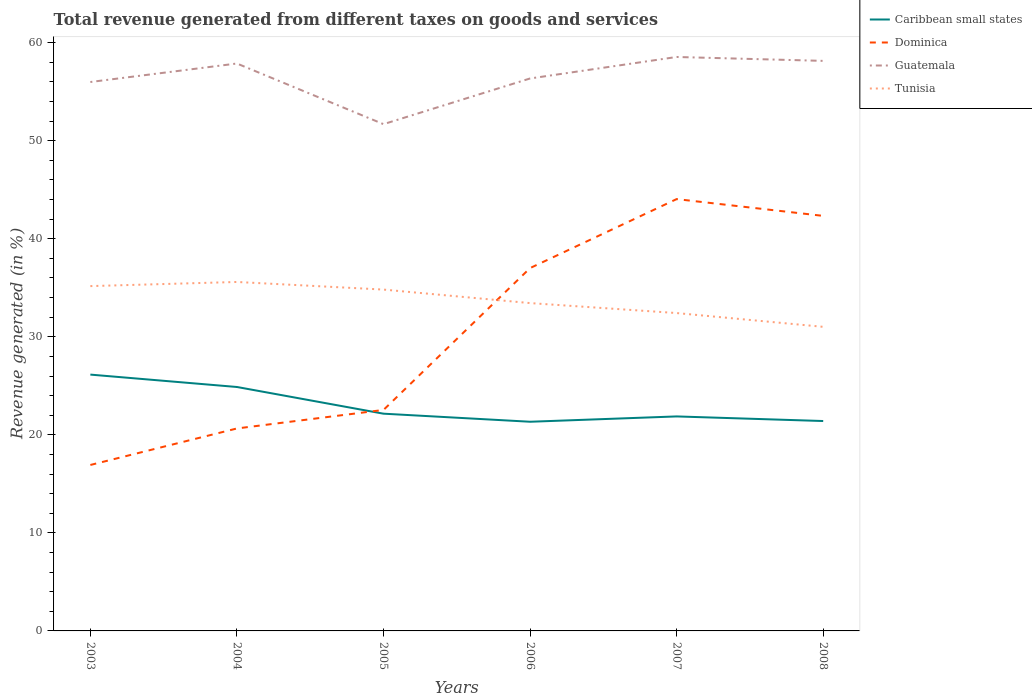How many different coloured lines are there?
Make the answer very short. 4. Across all years, what is the maximum total revenue generated in Tunisia?
Provide a succinct answer. 31.02. What is the total total revenue generated in Caribbean small states in the graph?
Your response must be concise. 1.26. What is the difference between the highest and the second highest total revenue generated in Guatemala?
Provide a succinct answer. 6.85. Is the total revenue generated in Tunisia strictly greater than the total revenue generated in Dominica over the years?
Keep it short and to the point. No. How many lines are there?
Your response must be concise. 4. How many years are there in the graph?
Your response must be concise. 6. What is the difference between two consecutive major ticks on the Y-axis?
Offer a very short reply. 10. Does the graph contain any zero values?
Ensure brevity in your answer.  No. Does the graph contain grids?
Provide a succinct answer. No. How many legend labels are there?
Provide a succinct answer. 4. How are the legend labels stacked?
Make the answer very short. Vertical. What is the title of the graph?
Make the answer very short. Total revenue generated from different taxes on goods and services. Does "Virgin Islands" appear as one of the legend labels in the graph?
Your response must be concise. No. What is the label or title of the Y-axis?
Offer a terse response. Revenue generated (in %). What is the Revenue generated (in %) in Caribbean small states in 2003?
Offer a very short reply. 26.14. What is the Revenue generated (in %) in Dominica in 2003?
Keep it short and to the point. 16.93. What is the Revenue generated (in %) in Guatemala in 2003?
Your answer should be very brief. 55.99. What is the Revenue generated (in %) in Tunisia in 2003?
Your answer should be compact. 35.17. What is the Revenue generated (in %) of Caribbean small states in 2004?
Ensure brevity in your answer.  24.88. What is the Revenue generated (in %) in Dominica in 2004?
Provide a succinct answer. 20.65. What is the Revenue generated (in %) in Guatemala in 2004?
Your response must be concise. 57.87. What is the Revenue generated (in %) of Tunisia in 2004?
Ensure brevity in your answer.  35.59. What is the Revenue generated (in %) of Caribbean small states in 2005?
Provide a succinct answer. 22.16. What is the Revenue generated (in %) in Dominica in 2005?
Provide a short and direct response. 22.54. What is the Revenue generated (in %) in Guatemala in 2005?
Ensure brevity in your answer.  51.69. What is the Revenue generated (in %) of Tunisia in 2005?
Provide a succinct answer. 34.82. What is the Revenue generated (in %) of Caribbean small states in 2006?
Ensure brevity in your answer.  21.34. What is the Revenue generated (in %) of Dominica in 2006?
Keep it short and to the point. 37.01. What is the Revenue generated (in %) of Guatemala in 2006?
Your response must be concise. 56.35. What is the Revenue generated (in %) of Tunisia in 2006?
Make the answer very short. 33.44. What is the Revenue generated (in %) of Caribbean small states in 2007?
Offer a terse response. 21.88. What is the Revenue generated (in %) of Dominica in 2007?
Offer a terse response. 44.04. What is the Revenue generated (in %) of Guatemala in 2007?
Provide a short and direct response. 58.54. What is the Revenue generated (in %) in Tunisia in 2007?
Offer a very short reply. 32.42. What is the Revenue generated (in %) of Caribbean small states in 2008?
Keep it short and to the point. 21.41. What is the Revenue generated (in %) of Dominica in 2008?
Offer a terse response. 42.33. What is the Revenue generated (in %) of Guatemala in 2008?
Your answer should be compact. 58.14. What is the Revenue generated (in %) in Tunisia in 2008?
Your response must be concise. 31.02. Across all years, what is the maximum Revenue generated (in %) in Caribbean small states?
Offer a very short reply. 26.14. Across all years, what is the maximum Revenue generated (in %) in Dominica?
Make the answer very short. 44.04. Across all years, what is the maximum Revenue generated (in %) of Guatemala?
Provide a succinct answer. 58.54. Across all years, what is the maximum Revenue generated (in %) of Tunisia?
Provide a succinct answer. 35.59. Across all years, what is the minimum Revenue generated (in %) of Caribbean small states?
Offer a terse response. 21.34. Across all years, what is the minimum Revenue generated (in %) of Dominica?
Ensure brevity in your answer.  16.93. Across all years, what is the minimum Revenue generated (in %) in Guatemala?
Give a very brief answer. 51.69. Across all years, what is the minimum Revenue generated (in %) in Tunisia?
Offer a terse response. 31.02. What is the total Revenue generated (in %) of Caribbean small states in the graph?
Ensure brevity in your answer.  137.8. What is the total Revenue generated (in %) in Dominica in the graph?
Your response must be concise. 183.5. What is the total Revenue generated (in %) of Guatemala in the graph?
Provide a succinct answer. 338.58. What is the total Revenue generated (in %) of Tunisia in the graph?
Give a very brief answer. 202.45. What is the difference between the Revenue generated (in %) of Caribbean small states in 2003 and that in 2004?
Your response must be concise. 1.26. What is the difference between the Revenue generated (in %) of Dominica in 2003 and that in 2004?
Your answer should be very brief. -3.72. What is the difference between the Revenue generated (in %) of Guatemala in 2003 and that in 2004?
Provide a short and direct response. -1.89. What is the difference between the Revenue generated (in %) of Tunisia in 2003 and that in 2004?
Your answer should be compact. -0.42. What is the difference between the Revenue generated (in %) in Caribbean small states in 2003 and that in 2005?
Provide a short and direct response. 3.99. What is the difference between the Revenue generated (in %) of Dominica in 2003 and that in 2005?
Keep it short and to the point. -5.61. What is the difference between the Revenue generated (in %) of Guatemala in 2003 and that in 2005?
Give a very brief answer. 4.3. What is the difference between the Revenue generated (in %) of Tunisia in 2003 and that in 2005?
Provide a short and direct response. 0.35. What is the difference between the Revenue generated (in %) in Caribbean small states in 2003 and that in 2006?
Ensure brevity in your answer.  4.81. What is the difference between the Revenue generated (in %) of Dominica in 2003 and that in 2006?
Provide a succinct answer. -20.08. What is the difference between the Revenue generated (in %) in Guatemala in 2003 and that in 2006?
Give a very brief answer. -0.36. What is the difference between the Revenue generated (in %) of Tunisia in 2003 and that in 2006?
Give a very brief answer. 1.73. What is the difference between the Revenue generated (in %) in Caribbean small states in 2003 and that in 2007?
Make the answer very short. 4.27. What is the difference between the Revenue generated (in %) of Dominica in 2003 and that in 2007?
Provide a succinct answer. -27.12. What is the difference between the Revenue generated (in %) of Guatemala in 2003 and that in 2007?
Keep it short and to the point. -2.55. What is the difference between the Revenue generated (in %) of Tunisia in 2003 and that in 2007?
Keep it short and to the point. 2.75. What is the difference between the Revenue generated (in %) in Caribbean small states in 2003 and that in 2008?
Keep it short and to the point. 4.74. What is the difference between the Revenue generated (in %) of Dominica in 2003 and that in 2008?
Make the answer very short. -25.41. What is the difference between the Revenue generated (in %) in Guatemala in 2003 and that in 2008?
Ensure brevity in your answer.  -2.15. What is the difference between the Revenue generated (in %) of Tunisia in 2003 and that in 2008?
Your answer should be very brief. 4.15. What is the difference between the Revenue generated (in %) of Caribbean small states in 2004 and that in 2005?
Your answer should be compact. 2.72. What is the difference between the Revenue generated (in %) in Dominica in 2004 and that in 2005?
Make the answer very short. -1.89. What is the difference between the Revenue generated (in %) in Guatemala in 2004 and that in 2005?
Keep it short and to the point. 6.19. What is the difference between the Revenue generated (in %) of Tunisia in 2004 and that in 2005?
Provide a short and direct response. 0.78. What is the difference between the Revenue generated (in %) of Caribbean small states in 2004 and that in 2006?
Give a very brief answer. 3.54. What is the difference between the Revenue generated (in %) in Dominica in 2004 and that in 2006?
Offer a terse response. -16.36. What is the difference between the Revenue generated (in %) of Guatemala in 2004 and that in 2006?
Offer a terse response. 1.53. What is the difference between the Revenue generated (in %) of Tunisia in 2004 and that in 2006?
Keep it short and to the point. 2.15. What is the difference between the Revenue generated (in %) in Caribbean small states in 2004 and that in 2007?
Your answer should be compact. 3. What is the difference between the Revenue generated (in %) in Dominica in 2004 and that in 2007?
Provide a short and direct response. -23.39. What is the difference between the Revenue generated (in %) of Guatemala in 2004 and that in 2007?
Ensure brevity in your answer.  -0.67. What is the difference between the Revenue generated (in %) of Tunisia in 2004 and that in 2007?
Your answer should be compact. 3.17. What is the difference between the Revenue generated (in %) of Caribbean small states in 2004 and that in 2008?
Provide a short and direct response. 3.47. What is the difference between the Revenue generated (in %) in Dominica in 2004 and that in 2008?
Keep it short and to the point. -21.68. What is the difference between the Revenue generated (in %) of Guatemala in 2004 and that in 2008?
Make the answer very short. -0.27. What is the difference between the Revenue generated (in %) of Tunisia in 2004 and that in 2008?
Your response must be concise. 4.58. What is the difference between the Revenue generated (in %) of Caribbean small states in 2005 and that in 2006?
Give a very brief answer. 0.82. What is the difference between the Revenue generated (in %) in Dominica in 2005 and that in 2006?
Make the answer very short. -14.47. What is the difference between the Revenue generated (in %) of Guatemala in 2005 and that in 2006?
Make the answer very short. -4.66. What is the difference between the Revenue generated (in %) of Tunisia in 2005 and that in 2006?
Your answer should be compact. 1.38. What is the difference between the Revenue generated (in %) in Caribbean small states in 2005 and that in 2007?
Your answer should be very brief. 0.28. What is the difference between the Revenue generated (in %) of Dominica in 2005 and that in 2007?
Provide a succinct answer. -21.51. What is the difference between the Revenue generated (in %) in Guatemala in 2005 and that in 2007?
Offer a terse response. -6.85. What is the difference between the Revenue generated (in %) in Tunisia in 2005 and that in 2007?
Offer a very short reply. 2.39. What is the difference between the Revenue generated (in %) in Caribbean small states in 2005 and that in 2008?
Give a very brief answer. 0.75. What is the difference between the Revenue generated (in %) in Dominica in 2005 and that in 2008?
Your answer should be compact. -19.79. What is the difference between the Revenue generated (in %) in Guatemala in 2005 and that in 2008?
Offer a terse response. -6.45. What is the difference between the Revenue generated (in %) of Tunisia in 2005 and that in 2008?
Provide a short and direct response. 3.8. What is the difference between the Revenue generated (in %) of Caribbean small states in 2006 and that in 2007?
Offer a terse response. -0.54. What is the difference between the Revenue generated (in %) of Dominica in 2006 and that in 2007?
Keep it short and to the point. -7.04. What is the difference between the Revenue generated (in %) in Guatemala in 2006 and that in 2007?
Provide a succinct answer. -2.19. What is the difference between the Revenue generated (in %) of Tunisia in 2006 and that in 2007?
Keep it short and to the point. 1.02. What is the difference between the Revenue generated (in %) of Caribbean small states in 2006 and that in 2008?
Offer a terse response. -0.07. What is the difference between the Revenue generated (in %) in Dominica in 2006 and that in 2008?
Make the answer very short. -5.32. What is the difference between the Revenue generated (in %) of Guatemala in 2006 and that in 2008?
Ensure brevity in your answer.  -1.79. What is the difference between the Revenue generated (in %) in Tunisia in 2006 and that in 2008?
Your answer should be compact. 2.42. What is the difference between the Revenue generated (in %) of Caribbean small states in 2007 and that in 2008?
Give a very brief answer. 0.47. What is the difference between the Revenue generated (in %) in Dominica in 2007 and that in 2008?
Your response must be concise. 1.71. What is the difference between the Revenue generated (in %) in Guatemala in 2007 and that in 2008?
Your answer should be very brief. 0.4. What is the difference between the Revenue generated (in %) of Tunisia in 2007 and that in 2008?
Your response must be concise. 1.41. What is the difference between the Revenue generated (in %) of Caribbean small states in 2003 and the Revenue generated (in %) of Dominica in 2004?
Keep it short and to the point. 5.49. What is the difference between the Revenue generated (in %) of Caribbean small states in 2003 and the Revenue generated (in %) of Guatemala in 2004?
Offer a terse response. -31.73. What is the difference between the Revenue generated (in %) of Caribbean small states in 2003 and the Revenue generated (in %) of Tunisia in 2004?
Keep it short and to the point. -9.45. What is the difference between the Revenue generated (in %) of Dominica in 2003 and the Revenue generated (in %) of Guatemala in 2004?
Make the answer very short. -40.95. What is the difference between the Revenue generated (in %) in Dominica in 2003 and the Revenue generated (in %) in Tunisia in 2004?
Your answer should be very brief. -18.67. What is the difference between the Revenue generated (in %) of Guatemala in 2003 and the Revenue generated (in %) of Tunisia in 2004?
Your response must be concise. 20.4. What is the difference between the Revenue generated (in %) in Caribbean small states in 2003 and the Revenue generated (in %) in Dominica in 2005?
Keep it short and to the point. 3.6. What is the difference between the Revenue generated (in %) of Caribbean small states in 2003 and the Revenue generated (in %) of Guatemala in 2005?
Make the answer very short. -25.54. What is the difference between the Revenue generated (in %) of Caribbean small states in 2003 and the Revenue generated (in %) of Tunisia in 2005?
Make the answer very short. -8.67. What is the difference between the Revenue generated (in %) in Dominica in 2003 and the Revenue generated (in %) in Guatemala in 2005?
Offer a terse response. -34.76. What is the difference between the Revenue generated (in %) of Dominica in 2003 and the Revenue generated (in %) of Tunisia in 2005?
Offer a very short reply. -17.89. What is the difference between the Revenue generated (in %) in Guatemala in 2003 and the Revenue generated (in %) in Tunisia in 2005?
Make the answer very short. 21.17. What is the difference between the Revenue generated (in %) in Caribbean small states in 2003 and the Revenue generated (in %) in Dominica in 2006?
Offer a terse response. -10.86. What is the difference between the Revenue generated (in %) of Caribbean small states in 2003 and the Revenue generated (in %) of Guatemala in 2006?
Make the answer very short. -30.2. What is the difference between the Revenue generated (in %) of Caribbean small states in 2003 and the Revenue generated (in %) of Tunisia in 2006?
Give a very brief answer. -7.29. What is the difference between the Revenue generated (in %) in Dominica in 2003 and the Revenue generated (in %) in Guatemala in 2006?
Make the answer very short. -39.42. What is the difference between the Revenue generated (in %) of Dominica in 2003 and the Revenue generated (in %) of Tunisia in 2006?
Your answer should be compact. -16.51. What is the difference between the Revenue generated (in %) of Guatemala in 2003 and the Revenue generated (in %) of Tunisia in 2006?
Keep it short and to the point. 22.55. What is the difference between the Revenue generated (in %) in Caribbean small states in 2003 and the Revenue generated (in %) in Dominica in 2007?
Give a very brief answer. -17.9. What is the difference between the Revenue generated (in %) in Caribbean small states in 2003 and the Revenue generated (in %) in Guatemala in 2007?
Your answer should be compact. -32.4. What is the difference between the Revenue generated (in %) of Caribbean small states in 2003 and the Revenue generated (in %) of Tunisia in 2007?
Offer a very short reply. -6.28. What is the difference between the Revenue generated (in %) of Dominica in 2003 and the Revenue generated (in %) of Guatemala in 2007?
Your answer should be compact. -41.61. What is the difference between the Revenue generated (in %) of Dominica in 2003 and the Revenue generated (in %) of Tunisia in 2007?
Ensure brevity in your answer.  -15.49. What is the difference between the Revenue generated (in %) of Guatemala in 2003 and the Revenue generated (in %) of Tunisia in 2007?
Provide a short and direct response. 23.57. What is the difference between the Revenue generated (in %) in Caribbean small states in 2003 and the Revenue generated (in %) in Dominica in 2008?
Ensure brevity in your answer.  -16.19. What is the difference between the Revenue generated (in %) of Caribbean small states in 2003 and the Revenue generated (in %) of Guatemala in 2008?
Your answer should be very brief. -32. What is the difference between the Revenue generated (in %) in Caribbean small states in 2003 and the Revenue generated (in %) in Tunisia in 2008?
Your answer should be compact. -4.87. What is the difference between the Revenue generated (in %) in Dominica in 2003 and the Revenue generated (in %) in Guatemala in 2008?
Ensure brevity in your answer.  -41.22. What is the difference between the Revenue generated (in %) of Dominica in 2003 and the Revenue generated (in %) of Tunisia in 2008?
Keep it short and to the point. -14.09. What is the difference between the Revenue generated (in %) of Guatemala in 2003 and the Revenue generated (in %) of Tunisia in 2008?
Keep it short and to the point. 24.97. What is the difference between the Revenue generated (in %) in Caribbean small states in 2004 and the Revenue generated (in %) in Dominica in 2005?
Your response must be concise. 2.34. What is the difference between the Revenue generated (in %) in Caribbean small states in 2004 and the Revenue generated (in %) in Guatemala in 2005?
Offer a terse response. -26.81. What is the difference between the Revenue generated (in %) in Caribbean small states in 2004 and the Revenue generated (in %) in Tunisia in 2005?
Offer a very short reply. -9.94. What is the difference between the Revenue generated (in %) in Dominica in 2004 and the Revenue generated (in %) in Guatemala in 2005?
Offer a terse response. -31.04. What is the difference between the Revenue generated (in %) of Dominica in 2004 and the Revenue generated (in %) of Tunisia in 2005?
Your response must be concise. -14.17. What is the difference between the Revenue generated (in %) of Guatemala in 2004 and the Revenue generated (in %) of Tunisia in 2005?
Give a very brief answer. 23.06. What is the difference between the Revenue generated (in %) of Caribbean small states in 2004 and the Revenue generated (in %) of Dominica in 2006?
Your answer should be compact. -12.13. What is the difference between the Revenue generated (in %) of Caribbean small states in 2004 and the Revenue generated (in %) of Guatemala in 2006?
Your answer should be compact. -31.47. What is the difference between the Revenue generated (in %) in Caribbean small states in 2004 and the Revenue generated (in %) in Tunisia in 2006?
Provide a succinct answer. -8.56. What is the difference between the Revenue generated (in %) in Dominica in 2004 and the Revenue generated (in %) in Guatemala in 2006?
Your answer should be very brief. -35.7. What is the difference between the Revenue generated (in %) in Dominica in 2004 and the Revenue generated (in %) in Tunisia in 2006?
Make the answer very short. -12.79. What is the difference between the Revenue generated (in %) in Guatemala in 2004 and the Revenue generated (in %) in Tunisia in 2006?
Offer a very short reply. 24.44. What is the difference between the Revenue generated (in %) of Caribbean small states in 2004 and the Revenue generated (in %) of Dominica in 2007?
Ensure brevity in your answer.  -19.16. What is the difference between the Revenue generated (in %) in Caribbean small states in 2004 and the Revenue generated (in %) in Guatemala in 2007?
Provide a short and direct response. -33.66. What is the difference between the Revenue generated (in %) of Caribbean small states in 2004 and the Revenue generated (in %) of Tunisia in 2007?
Provide a short and direct response. -7.54. What is the difference between the Revenue generated (in %) of Dominica in 2004 and the Revenue generated (in %) of Guatemala in 2007?
Give a very brief answer. -37.89. What is the difference between the Revenue generated (in %) in Dominica in 2004 and the Revenue generated (in %) in Tunisia in 2007?
Offer a terse response. -11.77. What is the difference between the Revenue generated (in %) in Guatemala in 2004 and the Revenue generated (in %) in Tunisia in 2007?
Your answer should be very brief. 25.45. What is the difference between the Revenue generated (in %) of Caribbean small states in 2004 and the Revenue generated (in %) of Dominica in 2008?
Make the answer very short. -17.45. What is the difference between the Revenue generated (in %) of Caribbean small states in 2004 and the Revenue generated (in %) of Guatemala in 2008?
Your answer should be very brief. -33.26. What is the difference between the Revenue generated (in %) of Caribbean small states in 2004 and the Revenue generated (in %) of Tunisia in 2008?
Provide a succinct answer. -6.14. What is the difference between the Revenue generated (in %) of Dominica in 2004 and the Revenue generated (in %) of Guatemala in 2008?
Give a very brief answer. -37.49. What is the difference between the Revenue generated (in %) of Dominica in 2004 and the Revenue generated (in %) of Tunisia in 2008?
Provide a succinct answer. -10.37. What is the difference between the Revenue generated (in %) in Guatemala in 2004 and the Revenue generated (in %) in Tunisia in 2008?
Your answer should be very brief. 26.86. What is the difference between the Revenue generated (in %) in Caribbean small states in 2005 and the Revenue generated (in %) in Dominica in 2006?
Give a very brief answer. -14.85. What is the difference between the Revenue generated (in %) of Caribbean small states in 2005 and the Revenue generated (in %) of Guatemala in 2006?
Offer a very short reply. -34.19. What is the difference between the Revenue generated (in %) of Caribbean small states in 2005 and the Revenue generated (in %) of Tunisia in 2006?
Your answer should be very brief. -11.28. What is the difference between the Revenue generated (in %) in Dominica in 2005 and the Revenue generated (in %) in Guatemala in 2006?
Make the answer very short. -33.81. What is the difference between the Revenue generated (in %) of Dominica in 2005 and the Revenue generated (in %) of Tunisia in 2006?
Your answer should be compact. -10.9. What is the difference between the Revenue generated (in %) of Guatemala in 2005 and the Revenue generated (in %) of Tunisia in 2006?
Give a very brief answer. 18.25. What is the difference between the Revenue generated (in %) of Caribbean small states in 2005 and the Revenue generated (in %) of Dominica in 2007?
Ensure brevity in your answer.  -21.89. What is the difference between the Revenue generated (in %) of Caribbean small states in 2005 and the Revenue generated (in %) of Guatemala in 2007?
Your response must be concise. -36.38. What is the difference between the Revenue generated (in %) of Caribbean small states in 2005 and the Revenue generated (in %) of Tunisia in 2007?
Make the answer very short. -10.26. What is the difference between the Revenue generated (in %) of Dominica in 2005 and the Revenue generated (in %) of Guatemala in 2007?
Provide a succinct answer. -36. What is the difference between the Revenue generated (in %) in Dominica in 2005 and the Revenue generated (in %) in Tunisia in 2007?
Offer a terse response. -9.88. What is the difference between the Revenue generated (in %) of Guatemala in 2005 and the Revenue generated (in %) of Tunisia in 2007?
Your response must be concise. 19.27. What is the difference between the Revenue generated (in %) in Caribbean small states in 2005 and the Revenue generated (in %) in Dominica in 2008?
Provide a succinct answer. -20.17. What is the difference between the Revenue generated (in %) of Caribbean small states in 2005 and the Revenue generated (in %) of Guatemala in 2008?
Ensure brevity in your answer.  -35.98. What is the difference between the Revenue generated (in %) of Caribbean small states in 2005 and the Revenue generated (in %) of Tunisia in 2008?
Your answer should be very brief. -8.86. What is the difference between the Revenue generated (in %) in Dominica in 2005 and the Revenue generated (in %) in Guatemala in 2008?
Your answer should be very brief. -35.6. What is the difference between the Revenue generated (in %) of Dominica in 2005 and the Revenue generated (in %) of Tunisia in 2008?
Give a very brief answer. -8.48. What is the difference between the Revenue generated (in %) of Guatemala in 2005 and the Revenue generated (in %) of Tunisia in 2008?
Provide a succinct answer. 20.67. What is the difference between the Revenue generated (in %) in Caribbean small states in 2006 and the Revenue generated (in %) in Dominica in 2007?
Your answer should be very brief. -22.71. What is the difference between the Revenue generated (in %) of Caribbean small states in 2006 and the Revenue generated (in %) of Guatemala in 2007?
Provide a succinct answer. -37.2. What is the difference between the Revenue generated (in %) in Caribbean small states in 2006 and the Revenue generated (in %) in Tunisia in 2007?
Give a very brief answer. -11.09. What is the difference between the Revenue generated (in %) of Dominica in 2006 and the Revenue generated (in %) of Guatemala in 2007?
Make the answer very short. -21.53. What is the difference between the Revenue generated (in %) in Dominica in 2006 and the Revenue generated (in %) in Tunisia in 2007?
Ensure brevity in your answer.  4.59. What is the difference between the Revenue generated (in %) in Guatemala in 2006 and the Revenue generated (in %) in Tunisia in 2007?
Your answer should be compact. 23.93. What is the difference between the Revenue generated (in %) of Caribbean small states in 2006 and the Revenue generated (in %) of Dominica in 2008?
Provide a succinct answer. -21. What is the difference between the Revenue generated (in %) in Caribbean small states in 2006 and the Revenue generated (in %) in Guatemala in 2008?
Ensure brevity in your answer.  -36.81. What is the difference between the Revenue generated (in %) in Caribbean small states in 2006 and the Revenue generated (in %) in Tunisia in 2008?
Your response must be concise. -9.68. What is the difference between the Revenue generated (in %) in Dominica in 2006 and the Revenue generated (in %) in Guatemala in 2008?
Your answer should be compact. -21.13. What is the difference between the Revenue generated (in %) of Dominica in 2006 and the Revenue generated (in %) of Tunisia in 2008?
Offer a terse response. 5.99. What is the difference between the Revenue generated (in %) in Guatemala in 2006 and the Revenue generated (in %) in Tunisia in 2008?
Your answer should be compact. 25.33. What is the difference between the Revenue generated (in %) in Caribbean small states in 2007 and the Revenue generated (in %) in Dominica in 2008?
Your answer should be compact. -20.45. What is the difference between the Revenue generated (in %) in Caribbean small states in 2007 and the Revenue generated (in %) in Guatemala in 2008?
Your answer should be compact. -36.26. What is the difference between the Revenue generated (in %) of Caribbean small states in 2007 and the Revenue generated (in %) of Tunisia in 2008?
Make the answer very short. -9.14. What is the difference between the Revenue generated (in %) of Dominica in 2007 and the Revenue generated (in %) of Guatemala in 2008?
Your answer should be very brief. -14.1. What is the difference between the Revenue generated (in %) in Dominica in 2007 and the Revenue generated (in %) in Tunisia in 2008?
Make the answer very short. 13.03. What is the difference between the Revenue generated (in %) of Guatemala in 2007 and the Revenue generated (in %) of Tunisia in 2008?
Provide a short and direct response. 27.52. What is the average Revenue generated (in %) in Caribbean small states per year?
Ensure brevity in your answer.  22.97. What is the average Revenue generated (in %) of Dominica per year?
Provide a short and direct response. 30.58. What is the average Revenue generated (in %) of Guatemala per year?
Your answer should be very brief. 56.43. What is the average Revenue generated (in %) in Tunisia per year?
Keep it short and to the point. 33.74. In the year 2003, what is the difference between the Revenue generated (in %) of Caribbean small states and Revenue generated (in %) of Dominica?
Your answer should be compact. 9.22. In the year 2003, what is the difference between the Revenue generated (in %) in Caribbean small states and Revenue generated (in %) in Guatemala?
Make the answer very short. -29.84. In the year 2003, what is the difference between the Revenue generated (in %) of Caribbean small states and Revenue generated (in %) of Tunisia?
Your answer should be compact. -9.03. In the year 2003, what is the difference between the Revenue generated (in %) of Dominica and Revenue generated (in %) of Guatemala?
Your answer should be compact. -39.06. In the year 2003, what is the difference between the Revenue generated (in %) of Dominica and Revenue generated (in %) of Tunisia?
Offer a very short reply. -18.24. In the year 2003, what is the difference between the Revenue generated (in %) of Guatemala and Revenue generated (in %) of Tunisia?
Provide a succinct answer. 20.82. In the year 2004, what is the difference between the Revenue generated (in %) in Caribbean small states and Revenue generated (in %) in Dominica?
Offer a very short reply. 4.23. In the year 2004, what is the difference between the Revenue generated (in %) in Caribbean small states and Revenue generated (in %) in Guatemala?
Provide a short and direct response. -32.99. In the year 2004, what is the difference between the Revenue generated (in %) of Caribbean small states and Revenue generated (in %) of Tunisia?
Ensure brevity in your answer.  -10.71. In the year 2004, what is the difference between the Revenue generated (in %) in Dominica and Revenue generated (in %) in Guatemala?
Keep it short and to the point. -37.22. In the year 2004, what is the difference between the Revenue generated (in %) of Dominica and Revenue generated (in %) of Tunisia?
Offer a terse response. -14.94. In the year 2004, what is the difference between the Revenue generated (in %) in Guatemala and Revenue generated (in %) in Tunisia?
Your answer should be compact. 22.28. In the year 2005, what is the difference between the Revenue generated (in %) of Caribbean small states and Revenue generated (in %) of Dominica?
Provide a succinct answer. -0.38. In the year 2005, what is the difference between the Revenue generated (in %) of Caribbean small states and Revenue generated (in %) of Guatemala?
Provide a short and direct response. -29.53. In the year 2005, what is the difference between the Revenue generated (in %) in Caribbean small states and Revenue generated (in %) in Tunisia?
Provide a short and direct response. -12.66. In the year 2005, what is the difference between the Revenue generated (in %) of Dominica and Revenue generated (in %) of Guatemala?
Offer a very short reply. -29.15. In the year 2005, what is the difference between the Revenue generated (in %) of Dominica and Revenue generated (in %) of Tunisia?
Offer a very short reply. -12.28. In the year 2005, what is the difference between the Revenue generated (in %) in Guatemala and Revenue generated (in %) in Tunisia?
Your response must be concise. 16.87. In the year 2006, what is the difference between the Revenue generated (in %) in Caribbean small states and Revenue generated (in %) in Dominica?
Your answer should be very brief. -15.67. In the year 2006, what is the difference between the Revenue generated (in %) in Caribbean small states and Revenue generated (in %) in Guatemala?
Ensure brevity in your answer.  -35.01. In the year 2006, what is the difference between the Revenue generated (in %) of Caribbean small states and Revenue generated (in %) of Tunisia?
Provide a short and direct response. -12.1. In the year 2006, what is the difference between the Revenue generated (in %) of Dominica and Revenue generated (in %) of Guatemala?
Offer a terse response. -19.34. In the year 2006, what is the difference between the Revenue generated (in %) in Dominica and Revenue generated (in %) in Tunisia?
Offer a terse response. 3.57. In the year 2006, what is the difference between the Revenue generated (in %) of Guatemala and Revenue generated (in %) of Tunisia?
Ensure brevity in your answer.  22.91. In the year 2007, what is the difference between the Revenue generated (in %) in Caribbean small states and Revenue generated (in %) in Dominica?
Keep it short and to the point. -22.17. In the year 2007, what is the difference between the Revenue generated (in %) of Caribbean small states and Revenue generated (in %) of Guatemala?
Give a very brief answer. -36.66. In the year 2007, what is the difference between the Revenue generated (in %) in Caribbean small states and Revenue generated (in %) in Tunisia?
Make the answer very short. -10.54. In the year 2007, what is the difference between the Revenue generated (in %) in Dominica and Revenue generated (in %) in Guatemala?
Offer a very short reply. -14.5. In the year 2007, what is the difference between the Revenue generated (in %) in Dominica and Revenue generated (in %) in Tunisia?
Offer a very short reply. 11.62. In the year 2007, what is the difference between the Revenue generated (in %) in Guatemala and Revenue generated (in %) in Tunisia?
Offer a very short reply. 26.12. In the year 2008, what is the difference between the Revenue generated (in %) of Caribbean small states and Revenue generated (in %) of Dominica?
Give a very brief answer. -20.92. In the year 2008, what is the difference between the Revenue generated (in %) in Caribbean small states and Revenue generated (in %) in Guatemala?
Provide a succinct answer. -36.73. In the year 2008, what is the difference between the Revenue generated (in %) in Caribbean small states and Revenue generated (in %) in Tunisia?
Ensure brevity in your answer.  -9.61. In the year 2008, what is the difference between the Revenue generated (in %) of Dominica and Revenue generated (in %) of Guatemala?
Your answer should be compact. -15.81. In the year 2008, what is the difference between the Revenue generated (in %) of Dominica and Revenue generated (in %) of Tunisia?
Keep it short and to the point. 11.32. In the year 2008, what is the difference between the Revenue generated (in %) in Guatemala and Revenue generated (in %) in Tunisia?
Your answer should be compact. 27.13. What is the ratio of the Revenue generated (in %) in Caribbean small states in 2003 to that in 2004?
Your answer should be compact. 1.05. What is the ratio of the Revenue generated (in %) of Dominica in 2003 to that in 2004?
Keep it short and to the point. 0.82. What is the ratio of the Revenue generated (in %) of Guatemala in 2003 to that in 2004?
Offer a very short reply. 0.97. What is the ratio of the Revenue generated (in %) of Tunisia in 2003 to that in 2004?
Keep it short and to the point. 0.99. What is the ratio of the Revenue generated (in %) in Caribbean small states in 2003 to that in 2005?
Keep it short and to the point. 1.18. What is the ratio of the Revenue generated (in %) in Dominica in 2003 to that in 2005?
Your response must be concise. 0.75. What is the ratio of the Revenue generated (in %) of Guatemala in 2003 to that in 2005?
Provide a succinct answer. 1.08. What is the ratio of the Revenue generated (in %) of Tunisia in 2003 to that in 2005?
Provide a succinct answer. 1.01. What is the ratio of the Revenue generated (in %) of Caribbean small states in 2003 to that in 2006?
Offer a terse response. 1.23. What is the ratio of the Revenue generated (in %) in Dominica in 2003 to that in 2006?
Make the answer very short. 0.46. What is the ratio of the Revenue generated (in %) in Tunisia in 2003 to that in 2006?
Make the answer very short. 1.05. What is the ratio of the Revenue generated (in %) of Caribbean small states in 2003 to that in 2007?
Provide a short and direct response. 1.2. What is the ratio of the Revenue generated (in %) in Dominica in 2003 to that in 2007?
Offer a terse response. 0.38. What is the ratio of the Revenue generated (in %) in Guatemala in 2003 to that in 2007?
Your response must be concise. 0.96. What is the ratio of the Revenue generated (in %) of Tunisia in 2003 to that in 2007?
Provide a succinct answer. 1.08. What is the ratio of the Revenue generated (in %) of Caribbean small states in 2003 to that in 2008?
Keep it short and to the point. 1.22. What is the ratio of the Revenue generated (in %) in Dominica in 2003 to that in 2008?
Ensure brevity in your answer.  0.4. What is the ratio of the Revenue generated (in %) of Guatemala in 2003 to that in 2008?
Give a very brief answer. 0.96. What is the ratio of the Revenue generated (in %) in Tunisia in 2003 to that in 2008?
Provide a succinct answer. 1.13. What is the ratio of the Revenue generated (in %) of Caribbean small states in 2004 to that in 2005?
Your answer should be very brief. 1.12. What is the ratio of the Revenue generated (in %) of Dominica in 2004 to that in 2005?
Your answer should be very brief. 0.92. What is the ratio of the Revenue generated (in %) of Guatemala in 2004 to that in 2005?
Your answer should be very brief. 1.12. What is the ratio of the Revenue generated (in %) of Tunisia in 2004 to that in 2005?
Offer a very short reply. 1.02. What is the ratio of the Revenue generated (in %) in Caribbean small states in 2004 to that in 2006?
Offer a very short reply. 1.17. What is the ratio of the Revenue generated (in %) in Dominica in 2004 to that in 2006?
Provide a short and direct response. 0.56. What is the ratio of the Revenue generated (in %) in Guatemala in 2004 to that in 2006?
Make the answer very short. 1.03. What is the ratio of the Revenue generated (in %) in Tunisia in 2004 to that in 2006?
Give a very brief answer. 1.06. What is the ratio of the Revenue generated (in %) of Caribbean small states in 2004 to that in 2007?
Provide a succinct answer. 1.14. What is the ratio of the Revenue generated (in %) of Dominica in 2004 to that in 2007?
Make the answer very short. 0.47. What is the ratio of the Revenue generated (in %) of Guatemala in 2004 to that in 2007?
Offer a terse response. 0.99. What is the ratio of the Revenue generated (in %) in Tunisia in 2004 to that in 2007?
Your response must be concise. 1.1. What is the ratio of the Revenue generated (in %) in Caribbean small states in 2004 to that in 2008?
Offer a very short reply. 1.16. What is the ratio of the Revenue generated (in %) of Dominica in 2004 to that in 2008?
Your response must be concise. 0.49. What is the ratio of the Revenue generated (in %) of Guatemala in 2004 to that in 2008?
Your answer should be very brief. 1. What is the ratio of the Revenue generated (in %) of Tunisia in 2004 to that in 2008?
Your answer should be compact. 1.15. What is the ratio of the Revenue generated (in %) in Caribbean small states in 2005 to that in 2006?
Your response must be concise. 1.04. What is the ratio of the Revenue generated (in %) of Dominica in 2005 to that in 2006?
Your answer should be very brief. 0.61. What is the ratio of the Revenue generated (in %) in Guatemala in 2005 to that in 2006?
Your answer should be compact. 0.92. What is the ratio of the Revenue generated (in %) in Tunisia in 2005 to that in 2006?
Your answer should be compact. 1.04. What is the ratio of the Revenue generated (in %) in Caribbean small states in 2005 to that in 2007?
Ensure brevity in your answer.  1.01. What is the ratio of the Revenue generated (in %) of Dominica in 2005 to that in 2007?
Offer a very short reply. 0.51. What is the ratio of the Revenue generated (in %) in Guatemala in 2005 to that in 2007?
Your answer should be very brief. 0.88. What is the ratio of the Revenue generated (in %) in Tunisia in 2005 to that in 2007?
Your answer should be very brief. 1.07. What is the ratio of the Revenue generated (in %) in Caribbean small states in 2005 to that in 2008?
Offer a terse response. 1.03. What is the ratio of the Revenue generated (in %) in Dominica in 2005 to that in 2008?
Ensure brevity in your answer.  0.53. What is the ratio of the Revenue generated (in %) in Guatemala in 2005 to that in 2008?
Offer a terse response. 0.89. What is the ratio of the Revenue generated (in %) in Tunisia in 2005 to that in 2008?
Make the answer very short. 1.12. What is the ratio of the Revenue generated (in %) of Caribbean small states in 2006 to that in 2007?
Your answer should be very brief. 0.98. What is the ratio of the Revenue generated (in %) of Dominica in 2006 to that in 2007?
Your answer should be compact. 0.84. What is the ratio of the Revenue generated (in %) in Guatemala in 2006 to that in 2007?
Offer a terse response. 0.96. What is the ratio of the Revenue generated (in %) in Tunisia in 2006 to that in 2007?
Keep it short and to the point. 1.03. What is the ratio of the Revenue generated (in %) of Dominica in 2006 to that in 2008?
Make the answer very short. 0.87. What is the ratio of the Revenue generated (in %) of Guatemala in 2006 to that in 2008?
Your answer should be compact. 0.97. What is the ratio of the Revenue generated (in %) in Tunisia in 2006 to that in 2008?
Your answer should be very brief. 1.08. What is the ratio of the Revenue generated (in %) in Caribbean small states in 2007 to that in 2008?
Make the answer very short. 1.02. What is the ratio of the Revenue generated (in %) of Dominica in 2007 to that in 2008?
Your response must be concise. 1.04. What is the ratio of the Revenue generated (in %) in Guatemala in 2007 to that in 2008?
Provide a succinct answer. 1.01. What is the ratio of the Revenue generated (in %) in Tunisia in 2007 to that in 2008?
Offer a very short reply. 1.05. What is the difference between the highest and the second highest Revenue generated (in %) in Caribbean small states?
Offer a very short reply. 1.26. What is the difference between the highest and the second highest Revenue generated (in %) of Dominica?
Your response must be concise. 1.71. What is the difference between the highest and the second highest Revenue generated (in %) of Guatemala?
Your answer should be compact. 0.4. What is the difference between the highest and the second highest Revenue generated (in %) in Tunisia?
Your response must be concise. 0.42. What is the difference between the highest and the lowest Revenue generated (in %) of Caribbean small states?
Your response must be concise. 4.81. What is the difference between the highest and the lowest Revenue generated (in %) in Dominica?
Your response must be concise. 27.12. What is the difference between the highest and the lowest Revenue generated (in %) of Guatemala?
Give a very brief answer. 6.85. What is the difference between the highest and the lowest Revenue generated (in %) in Tunisia?
Offer a very short reply. 4.58. 